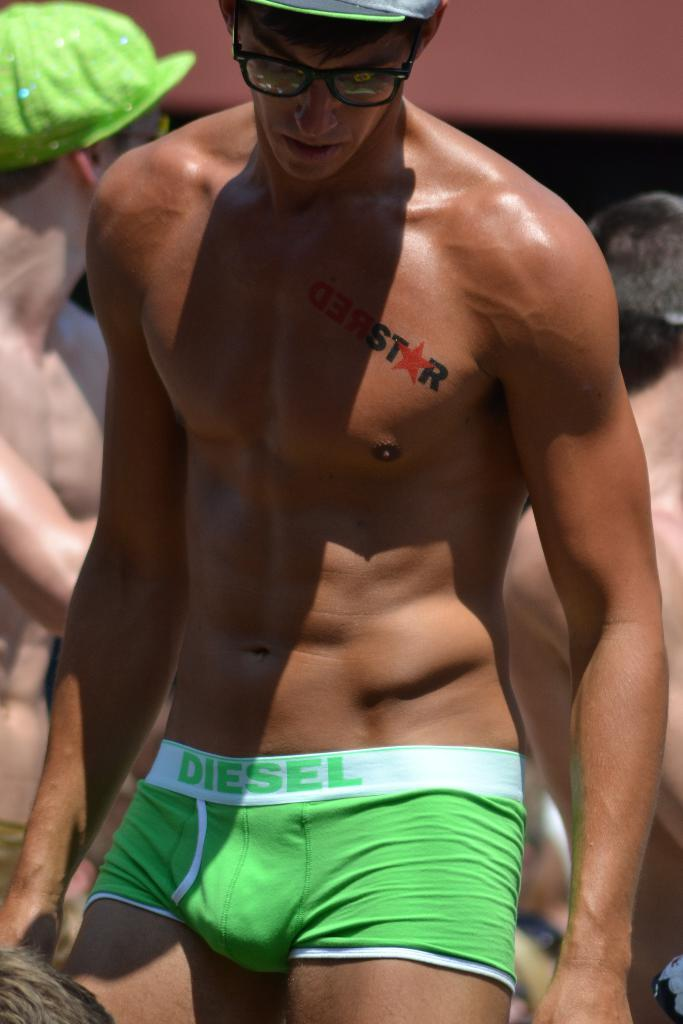<image>
Give a short and clear explanation of the subsequent image. A man with no shirt has on briefs that read diesel 